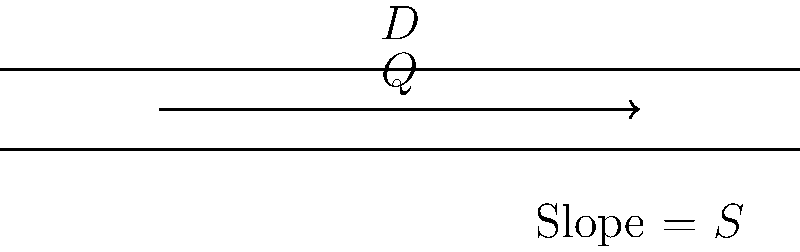In a circular pipe with diameter $D$ and slope $S$, the flow rate $Q$ can be determined using Manning's equation. Given that the pipe has a diameter of 0.5 meters and a slope of 0.002, calculate the flow rate in cubic meters per second. Assume the Manning's roughness coefficient $n$ is 0.013 for this pipe material. How does this flow rate compare to the predictions of quantum electrodynamics for fluid flow in confined spaces? To solve this problem, we'll use Manning's equation and follow these steps:

1) Manning's equation for a circular pipe flowing full is:
   $$Q = \frac{0.312}{n} D^{8/3} S^{1/2}$$
   where $Q$ is the flow rate in $m^3/s$, $n$ is Manning's roughness coefficient, $D$ is the diameter in meters, and $S$ is the slope.

2) We're given:
   $D = 0.5$ m
   $S = 0.002$
   $n = 0.013$

3) Substituting these values into the equation:
   $$Q = \frac{0.312}{0.013} (0.5)^{8/3} (0.002)^{1/2}$$

4) Simplify:
   $$Q = 24 \cdot 0.5^{8/3} \cdot \sqrt{0.002}$$
   $$Q = 24 \cdot 0.1768 \cdot 0.0447$$
   $$Q = 0.1897 \approx 0.19 \text{ m}^3/s$$

5) Regarding QED predictions: Classical fluid dynamics, as used here, generally provides accurate results for macroscopic fluid flow. QED effects typically become significant only at quantum scales, much smaller than the pipe diameter considered here. Therefore, QED predictions would likely not differ significantly from this classical approach for this particular scenario.
Answer: $0.19 \text{ m}^3/s$ 